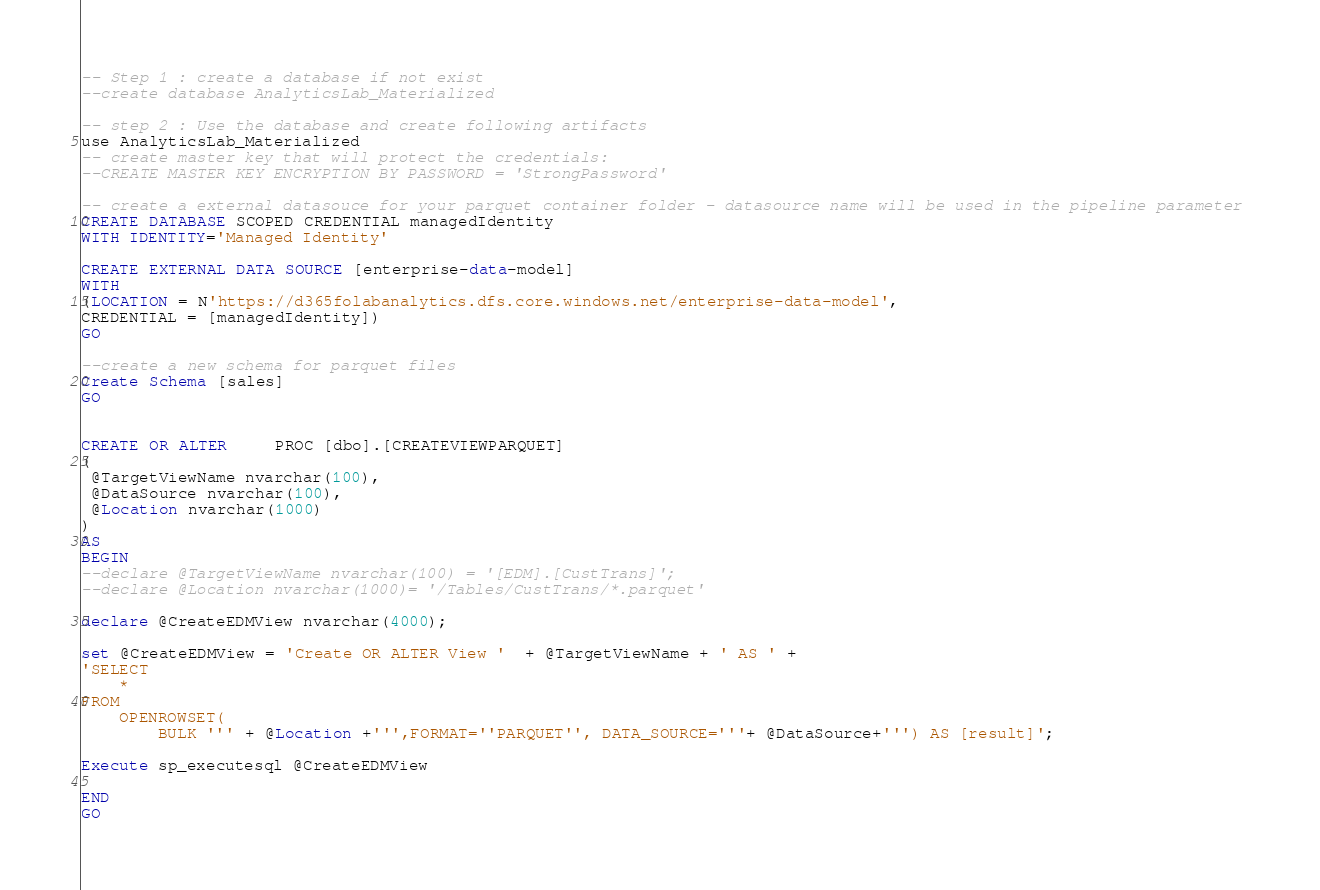<code> <loc_0><loc_0><loc_500><loc_500><_SQL_>-- Step 1 : create a database if not exist 
--create database AnalyticsLab_Materialized

-- step 2 : Use the database and create following artifacts
use AnalyticsLab_Materialized
-- create master key that will protect the credentials:
--CREATE MASTER KEY ENCRYPTION BY PASSWORD = 'StrongPassword'

-- create a external datasouce for your parquet container folder - datasource name will be used in the pipeline parameter 
CREATE DATABASE SCOPED CREDENTIAL managedIdentity
WITH IDENTITY='Managed Identity'

CREATE EXTERNAL DATA SOURCE [enterprise-data-model] 
WITH 
(LOCATION = N'https://d365folabanalytics.dfs.core.windows.net/enterprise-data-model', 
CREDENTIAL = [managedIdentity])
GO

--create a new schema for parquet files 
Create Schema [sales]
GO


CREATE OR ALTER     PROC [dbo].[CREATEVIEWPARQUET]
(
 @TargetViewName nvarchar(100),
 @DataSource nvarchar(100),
 @Location nvarchar(1000)
)
AS
BEGIN
--declare @TargetViewName nvarchar(100) = '[EDM].[CustTrans]';
--declare @Location nvarchar(1000)= '/Tables/CustTrans/*.parquet'

declare @CreateEDMView nvarchar(4000);

set @CreateEDMView = 'Create OR ALTER View '  + @TargetViewName + ' AS ' +
'SELECT
    *
FROM
    OPENROWSET(
        BULK ''' + @Location +''',FORMAT=''PARQUET'', DATA_SOURCE='''+ @DataSource+''') AS [result]';

Execute sp_executesql @CreateEDMView

END
GO






</code> 